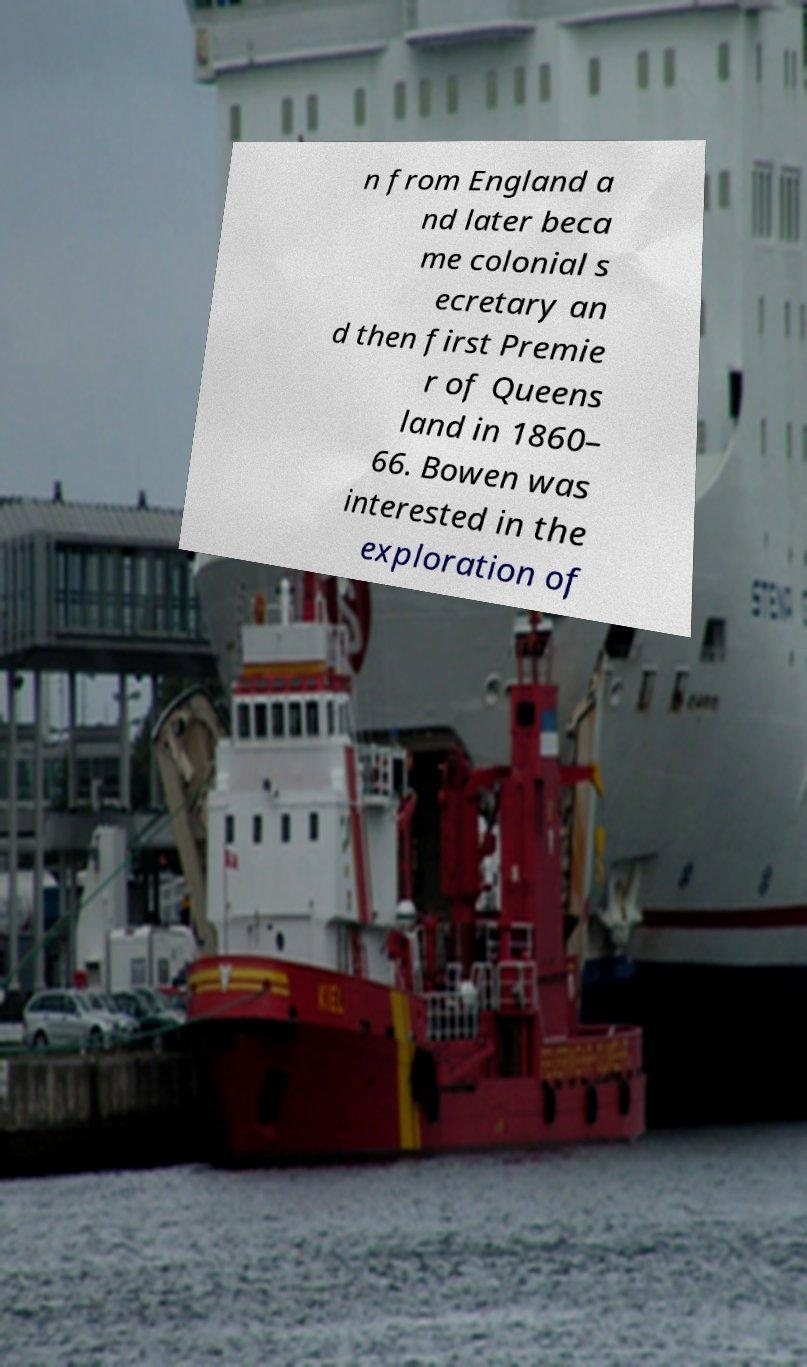For documentation purposes, I need the text within this image transcribed. Could you provide that? n from England a nd later beca me colonial s ecretary an d then first Premie r of Queens land in 1860– 66. Bowen was interested in the exploration of 